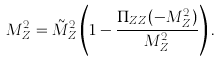<formula> <loc_0><loc_0><loc_500><loc_500>M _ { Z } ^ { 2 } = \tilde { M } _ { Z } ^ { 2 } \left ( 1 - \frac { \Pi _ { Z Z } ( - M _ { Z } ^ { 2 } ) } { M _ { Z } ^ { 2 } } \right ) .</formula> 